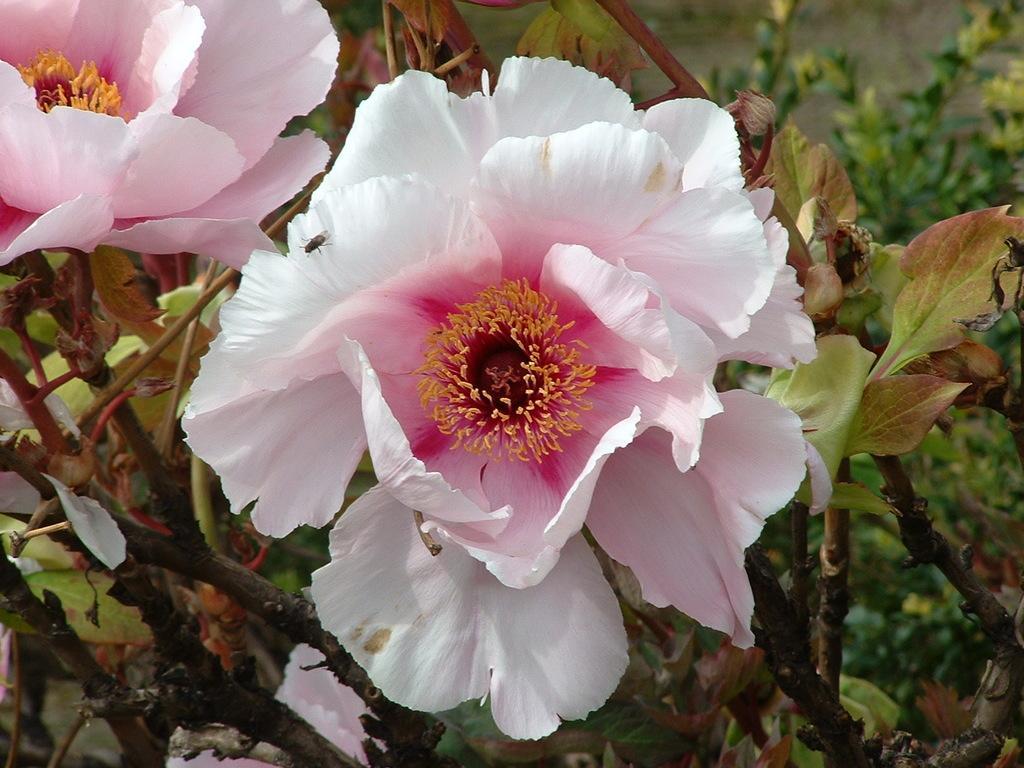Could you give a brief overview of what you see in this image? In this image we can see flowers to a plant, in which we can see an insect on a flower. In the background, we can see some plants. 